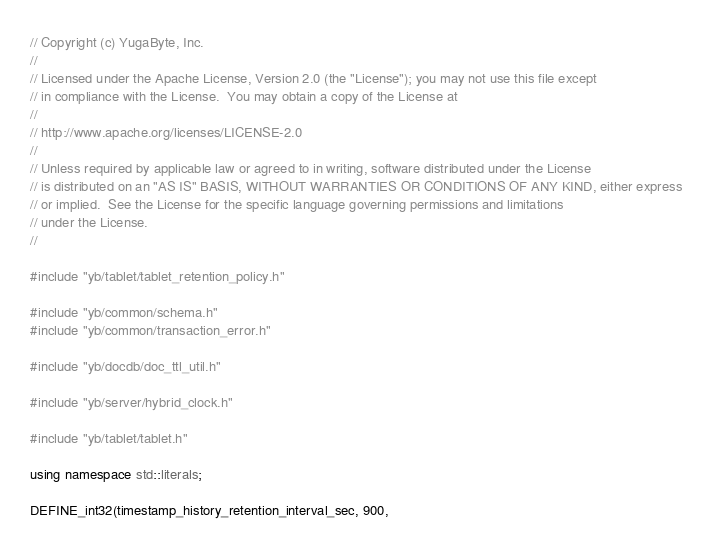<code> <loc_0><loc_0><loc_500><loc_500><_C++_>// Copyright (c) YugaByte, Inc.
//
// Licensed under the Apache License, Version 2.0 (the "License"); you may not use this file except
// in compliance with the License.  You may obtain a copy of the License at
//
// http://www.apache.org/licenses/LICENSE-2.0
//
// Unless required by applicable law or agreed to in writing, software distributed under the License
// is distributed on an "AS IS" BASIS, WITHOUT WARRANTIES OR CONDITIONS OF ANY KIND, either express
// or implied.  See the License for the specific language governing permissions and limitations
// under the License.
//

#include "yb/tablet/tablet_retention_policy.h"

#include "yb/common/schema.h"
#include "yb/common/transaction_error.h"

#include "yb/docdb/doc_ttl_util.h"

#include "yb/server/hybrid_clock.h"

#include "yb/tablet/tablet.h"

using namespace std::literals;

DEFINE_int32(timestamp_history_retention_interval_sec, 900,</code> 